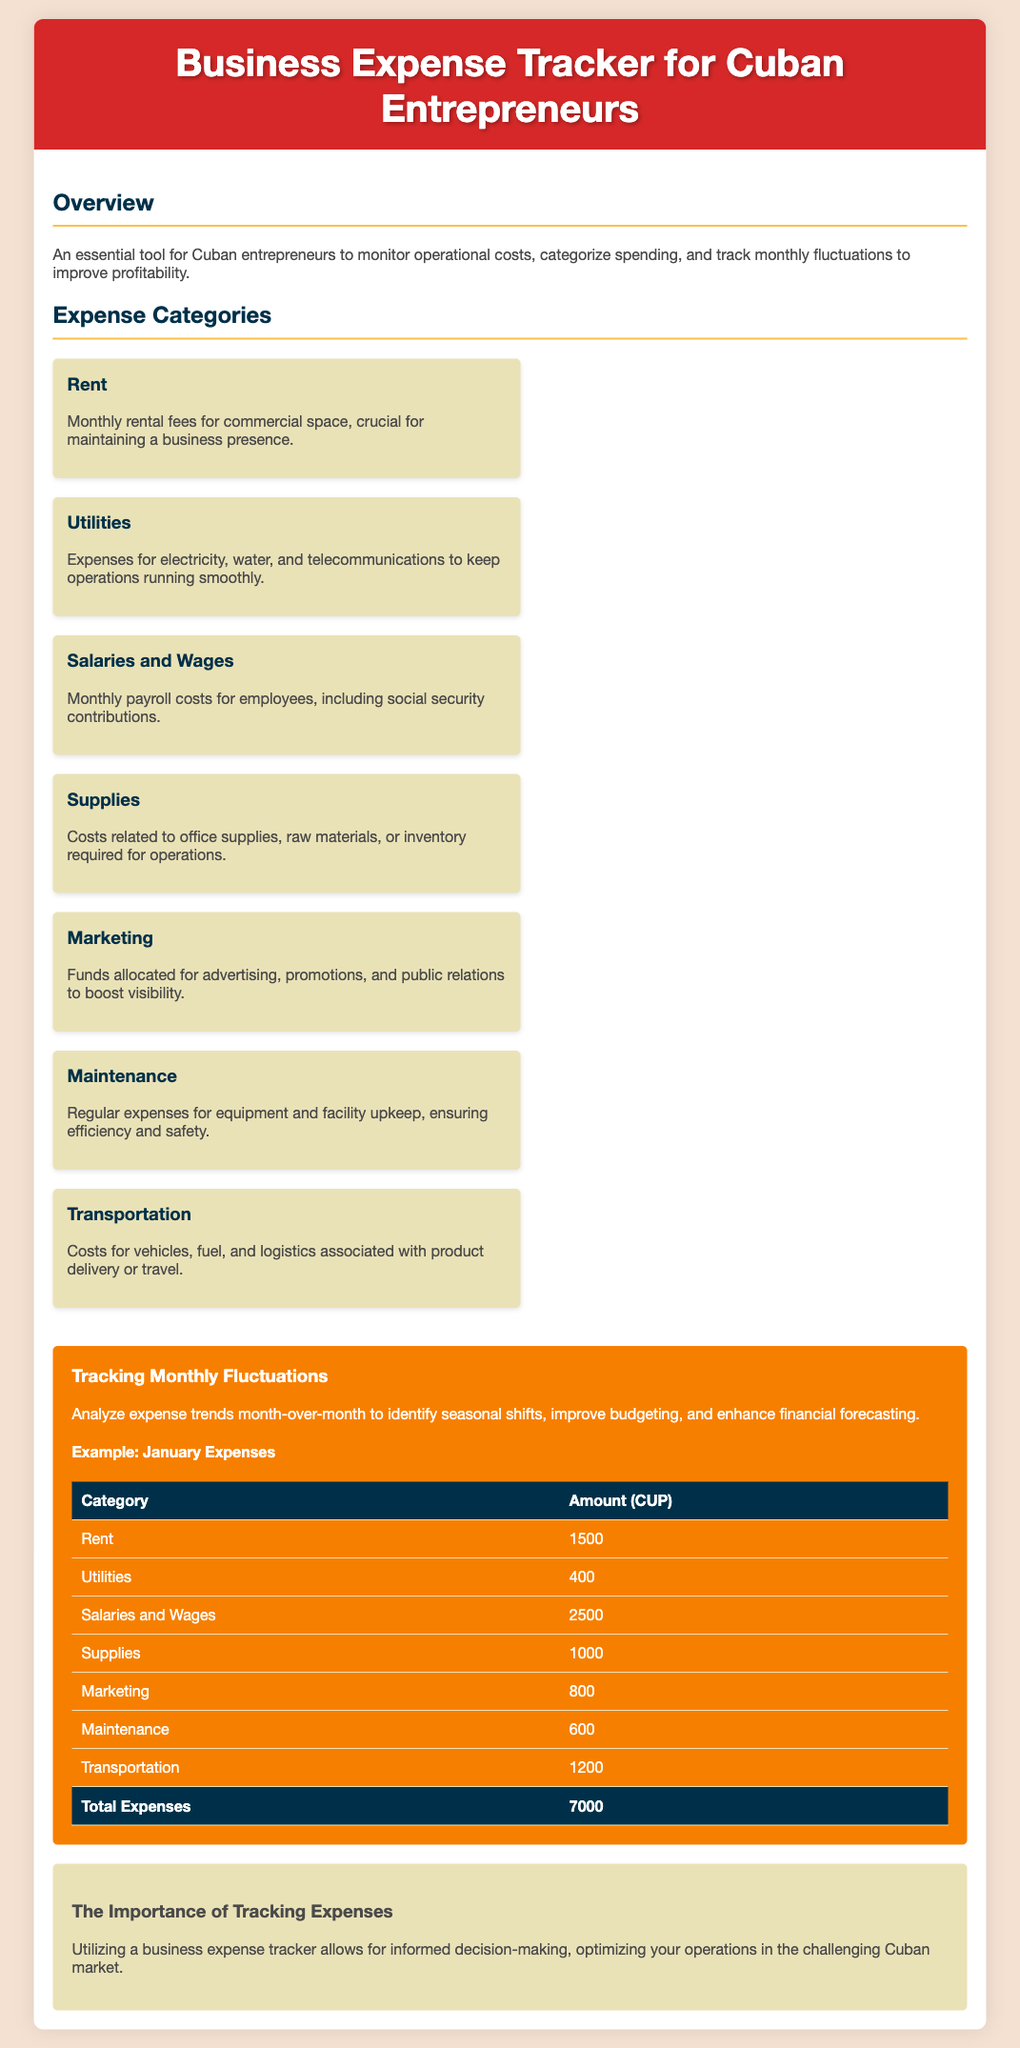What is the title of the document? The title of the document is stated in the header section and indicates the main subject of the content.
Answer: Business Expense Tracker for Cuban Entrepreneurs What are the total expenses for January? The total expenses for January are provided in the table summarizing the expenses by category.
Answer: 7000 How much is allocated for Salaries and Wages? The amount allocated for Salaries and Wages is listed in the monthly expenses table under that specific category.
Answer: 2500 What does the Marketing category include? The document provides a description of what the Marketing category covers, enhancing understanding of where funds are allocated.
Answer: Advertising, promotions, and public relations Which expense category has the highest cost? By comparing the amounts listed in the January Expenses table, the category with the highest cost can be identified.
Answer: Salaries and Wages What purpose does the Expense Tracker serve? The document describes the purpose of the Expense Tracker in the introduction, highlighting its use for business analysis.
Answer: Monitor operational costs What is the color of the fluctuations section? The document uses specific colors to distinguish different sections visually, including the fluctuations section.
Answer: Orange How are the expenses categorized? The document lists various categories, providing a structured overview of different expenses.
Answer: Rent, Utilities, Salaries and Wages, Supplies, Marketing, Maintenance, Transportation What analytical method is emphasized for understanding expenses? The document mentions a specific analytical approach when discussing monthly fluctuations in expenses for better budgeting.
Answer: Analyze expense trends month-over-month 